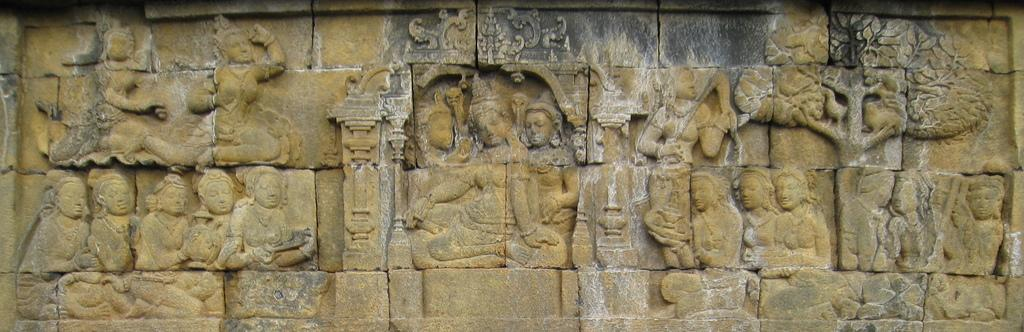What is depicted on the wall in the image? There are sculptures on the wall in the image. What type of clock is hanging on the wall next to the sculptures in the image? There is no clock present in the image; it only features sculptures on the wall. 